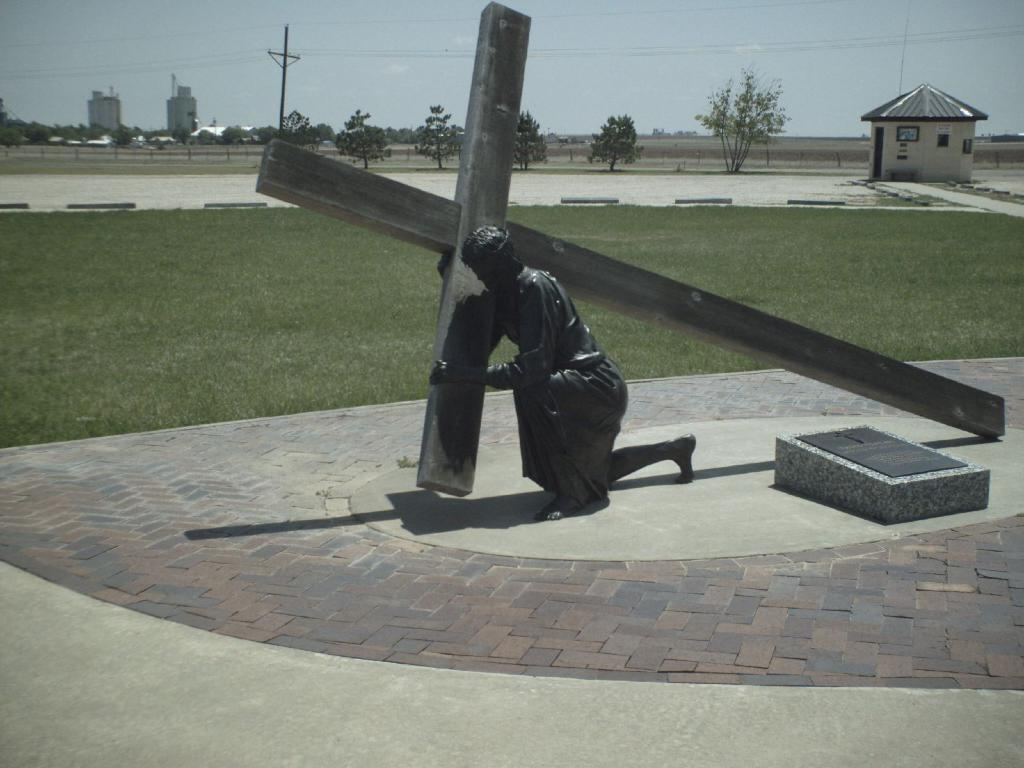What can be seen in the background of the image? In the background of the image, there is a shed, trees, and buildings. Are there any structures with wires in the image? Yes, there is a pole with wires in the image. Are there any other poles visible in the image? Yes, there are other poles in the image. What is visible at the bottom of the image? The ground is visible at the bottom of the image. Can you see a cow wearing a jewel in the image? There is no cow or jewel present in the image. Is the image showing any motion or movement? The image itself is static, and there is no indication of motion or movement within the scene depicted. 